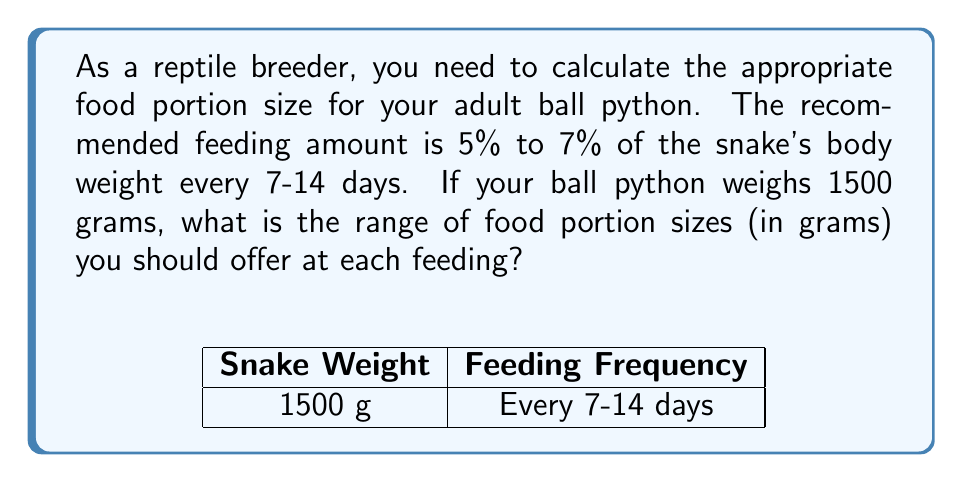Provide a solution to this math problem. Let's approach this step-by-step:

1) We need to calculate 5% and 7% of the snake's body weight.

2) To convert a percentage to a decimal, we divide by 100:
   5% = 5 ÷ 100 = 0.05
   7% = 7 ÷ 100 = 0.07

3) Now, let's calculate the minimum portion size (5% of body weight):
   $$ \text{Minimum} = 1500 \times 0.05 = 75 \text{ grams} $$

4) And the maximum portion size (7% of body weight):
   $$ \text{Maximum} = 1500 \times 0.07 = 105 \text{ grams} $$

5) Therefore, the range of food portion sizes is 75 grams to 105 grams.

This calculation ensures that you're feeding your ball python an appropriate amount based on its body weight, which is crucial for maintaining optimal nutrition in your reptile collection.
Answer: 75-105 grams 